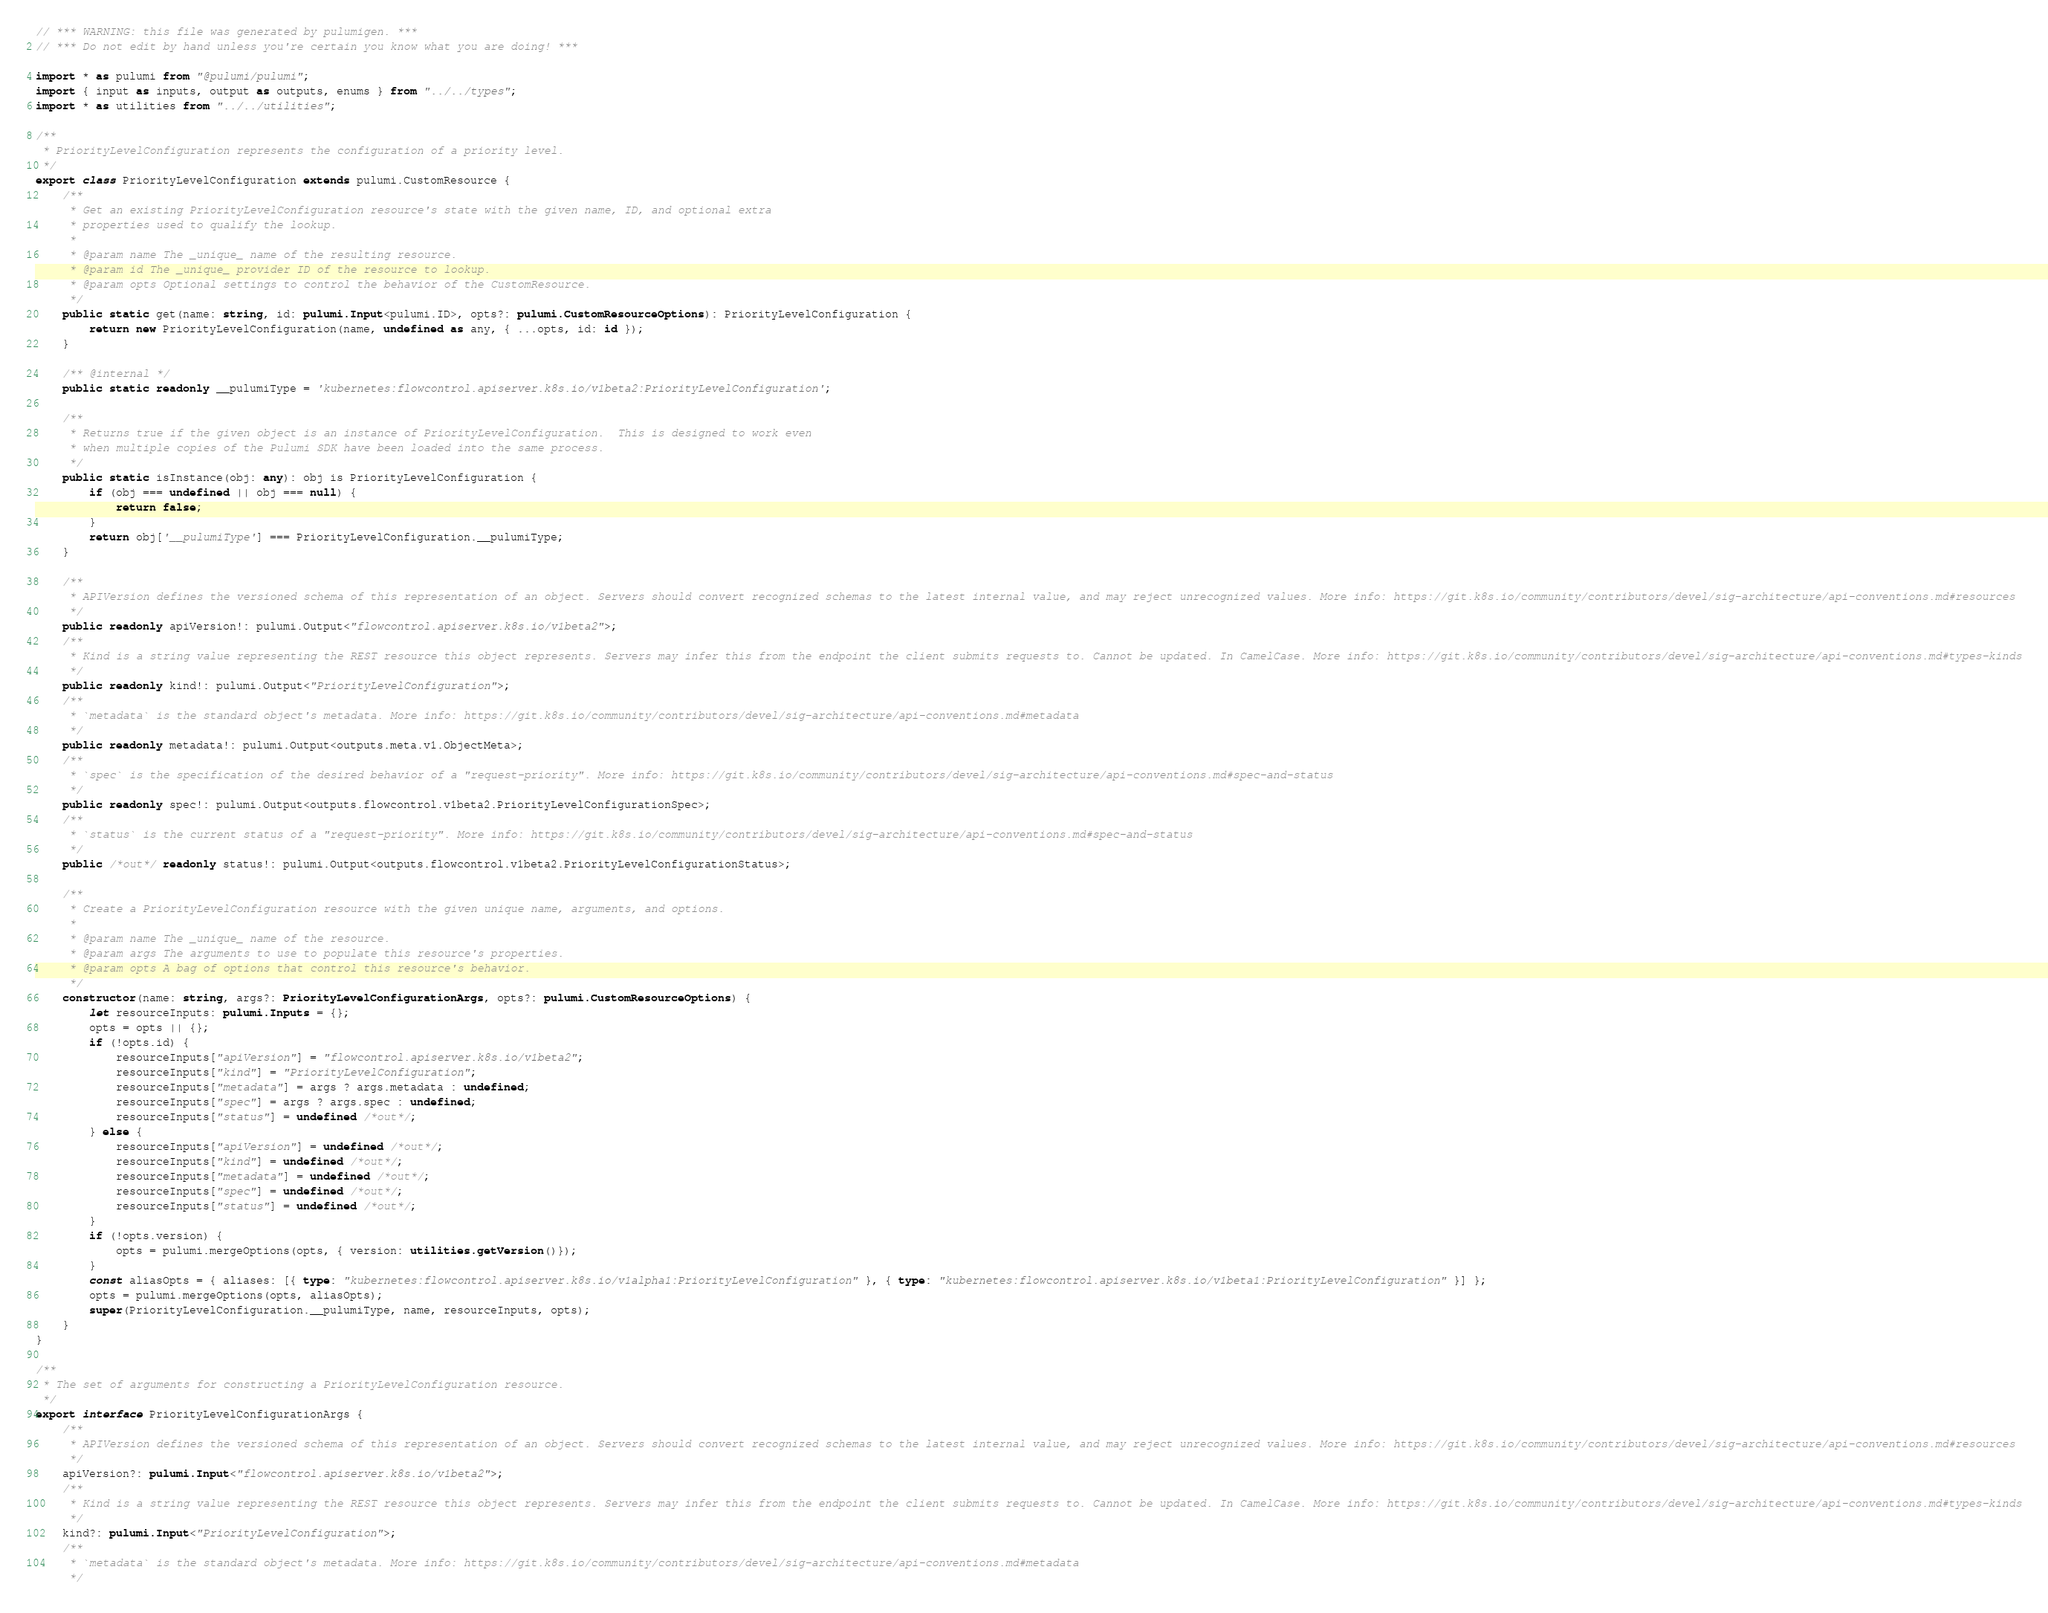Convert code to text. <code><loc_0><loc_0><loc_500><loc_500><_TypeScript_>// *** WARNING: this file was generated by pulumigen. ***
// *** Do not edit by hand unless you're certain you know what you are doing! ***

import * as pulumi from "@pulumi/pulumi";
import { input as inputs, output as outputs, enums } from "../../types";
import * as utilities from "../../utilities";

/**
 * PriorityLevelConfiguration represents the configuration of a priority level.
 */
export class PriorityLevelConfiguration extends pulumi.CustomResource {
    /**
     * Get an existing PriorityLevelConfiguration resource's state with the given name, ID, and optional extra
     * properties used to qualify the lookup.
     *
     * @param name The _unique_ name of the resulting resource.
     * @param id The _unique_ provider ID of the resource to lookup.
     * @param opts Optional settings to control the behavior of the CustomResource.
     */
    public static get(name: string, id: pulumi.Input<pulumi.ID>, opts?: pulumi.CustomResourceOptions): PriorityLevelConfiguration {
        return new PriorityLevelConfiguration(name, undefined as any, { ...opts, id: id });
    }

    /** @internal */
    public static readonly __pulumiType = 'kubernetes:flowcontrol.apiserver.k8s.io/v1beta2:PriorityLevelConfiguration';

    /**
     * Returns true if the given object is an instance of PriorityLevelConfiguration.  This is designed to work even
     * when multiple copies of the Pulumi SDK have been loaded into the same process.
     */
    public static isInstance(obj: any): obj is PriorityLevelConfiguration {
        if (obj === undefined || obj === null) {
            return false;
        }
        return obj['__pulumiType'] === PriorityLevelConfiguration.__pulumiType;
    }

    /**
     * APIVersion defines the versioned schema of this representation of an object. Servers should convert recognized schemas to the latest internal value, and may reject unrecognized values. More info: https://git.k8s.io/community/contributors/devel/sig-architecture/api-conventions.md#resources
     */
    public readonly apiVersion!: pulumi.Output<"flowcontrol.apiserver.k8s.io/v1beta2">;
    /**
     * Kind is a string value representing the REST resource this object represents. Servers may infer this from the endpoint the client submits requests to. Cannot be updated. In CamelCase. More info: https://git.k8s.io/community/contributors/devel/sig-architecture/api-conventions.md#types-kinds
     */
    public readonly kind!: pulumi.Output<"PriorityLevelConfiguration">;
    /**
     * `metadata` is the standard object's metadata. More info: https://git.k8s.io/community/contributors/devel/sig-architecture/api-conventions.md#metadata
     */
    public readonly metadata!: pulumi.Output<outputs.meta.v1.ObjectMeta>;
    /**
     * `spec` is the specification of the desired behavior of a "request-priority". More info: https://git.k8s.io/community/contributors/devel/sig-architecture/api-conventions.md#spec-and-status
     */
    public readonly spec!: pulumi.Output<outputs.flowcontrol.v1beta2.PriorityLevelConfigurationSpec>;
    /**
     * `status` is the current status of a "request-priority". More info: https://git.k8s.io/community/contributors/devel/sig-architecture/api-conventions.md#spec-and-status
     */
    public /*out*/ readonly status!: pulumi.Output<outputs.flowcontrol.v1beta2.PriorityLevelConfigurationStatus>;

    /**
     * Create a PriorityLevelConfiguration resource with the given unique name, arguments, and options.
     *
     * @param name The _unique_ name of the resource.
     * @param args The arguments to use to populate this resource's properties.
     * @param opts A bag of options that control this resource's behavior.
     */
    constructor(name: string, args?: PriorityLevelConfigurationArgs, opts?: pulumi.CustomResourceOptions) {
        let resourceInputs: pulumi.Inputs = {};
        opts = opts || {};
        if (!opts.id) {
            resourceInputs["apiVersion"] = "flowcontrol.apiserver.k8s.io/v1beta2";
            resourceInputs["kind"] = "PriorityLevelConfiguration";
            resourceInputs["metadata"] = args ? args.metadata : undefined;
            resourceInputs["spec"] = args ? args.spec : undefined;
            resourceInputs["status"] = undefined /*out*/;
        } else {
            resourceInputs["apiVersion"] = undefined /*out*/;
            resourceInputs["kind"] = undefined /*out*/;
            resourceInputs["metadata"] = undefined /*out*/;
            resourceInputs["spec"] = undefined /*out*/;
            resourceInputs["status"] = undefined /*out*/;
        }
        if (!opts.version) {
            opts = pulumi.mergeOptions(opts, { version: utilities.getVersion()});
        }
        const aliasOpts = { aliases: [{ type: "kubernetes:flowcontrol.apiserver.k8s.io/v1alpha1:PriorityLevelConfiguration" }, { type: "kubernetes:flowcontrol.apiserver.k8s.io/v1beta1:PriorityLevelConfiguration" }] };
        opts = pulumi.mergeOptions(opts, aliasOpts);
        super(PriorityLevelConfiguration.__pulumiType, name, resourceInputs, opts);
    }
}

/**
 * The set of arguments for constructing a PriorityLevelConfiguration resource.
 */
export interface PriorityLevelConfigurationArgs {
    /**
     * APIVersion defines the versioned schema of this representation of an object. Servers should convert recognized schemas to the latest internal value, and may reject unrecognized values. More info: https://git.k8s.io/community/contributors/devel/sig-architecture/api-conventions.md#resources
     */
    apiVersion?: pulumi.Input<"flowcontrol.apiserver.k8s.io/v1beta2">;
    /**
     * Kind is a string value representing the REST resource this object represents. Servers may infer this from the endpoint the client submits requests to. Cannot be updated. In CamelCase. More info: https://git.k8s.io/community/contributors/devel/sig-architecture/api-conventions.md#types-kinds
     */
    kind?: pulumi.Input<"PriorityLevelConfiguration">;
    /**
     * `metadata` is the standard object's metadata. More info: https://git.k8s.io/community/contributors/devel/sig-architecture/api-conventions.md#metadata
     */</code> 